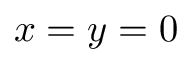Convert formula to latex. <formula><loc_0><loc_0><loc_500><loc_500>x = y = 0</formula> 